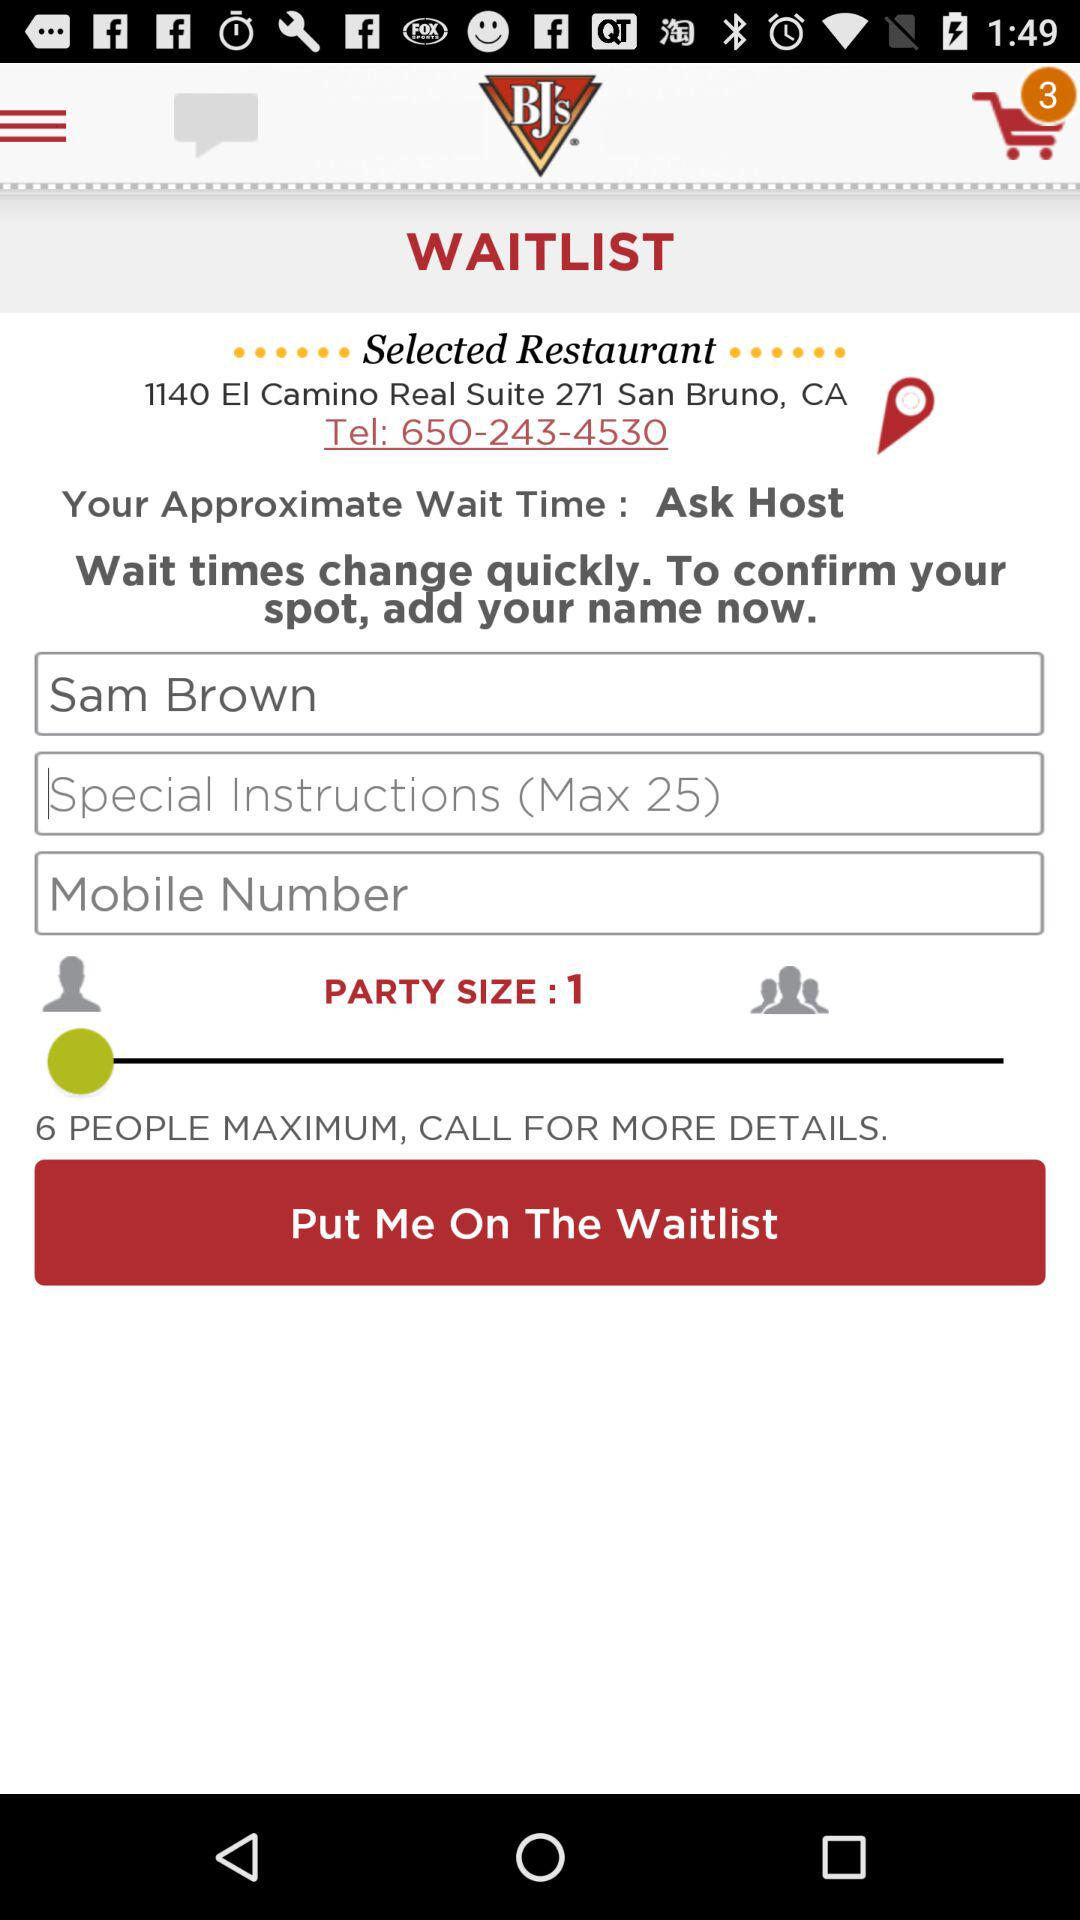How many people are currently in the party?
Answer the question using a single word or phrase. 1 